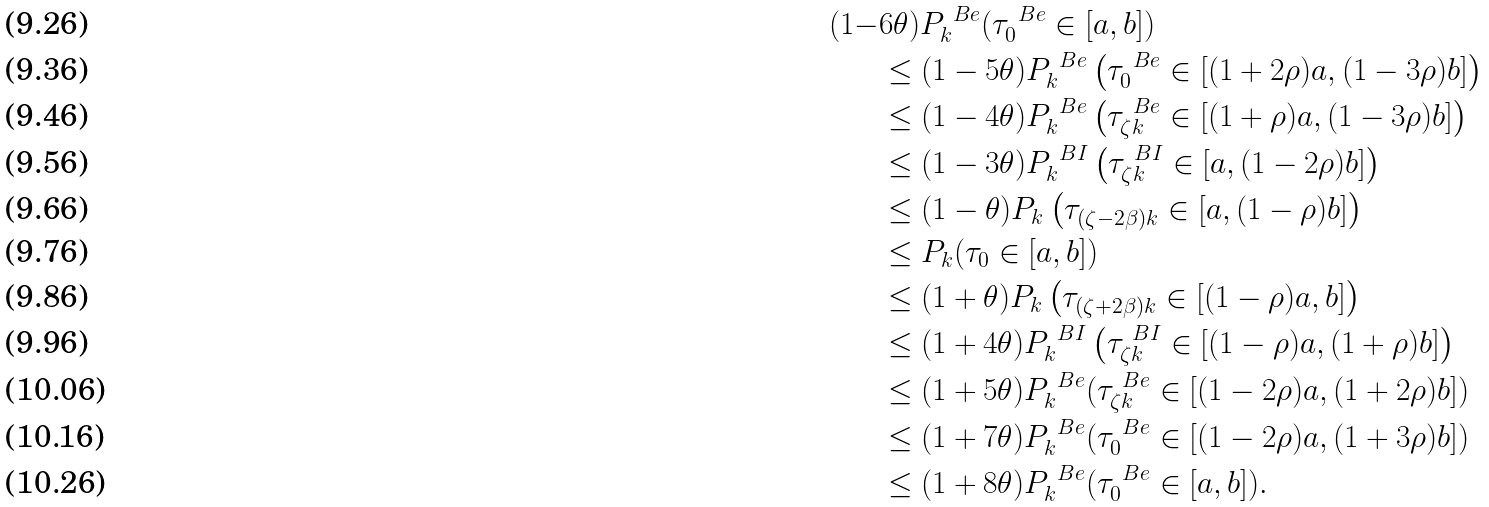Convert formula to latex. <formula><loc_0><loc_0><loc_500><loc_500>( 1 - & 6 \theta ) P _ { k } ^ { \ B e } ( \tau _ { 0 } ^ { \ B e } \in [ a , b ] ) \\ & \leq ( 1 - 5 \theta ) P _ { k } ^ { \ B e } \left ( \tau _ { 0 } ^ { \ B e } \in [ ( 1 + 2 \rho ) a , ( 1 - 3 \rho ) b ] \right ) \\ & \leq ( 1 - 4 \theta ) P _ { k } ^ { \ B e } \left ( \tau _ { \zeta k } ^ { \ B e } \in [ ( 1 + \rho ) a , ( 1 - 3 \rho ) b ] \right ) \\ & \leq ( 1 - 3 \theta ) P _ { k } ^ { \ B I } \left ( \tau _ { \zeta k } ^ { \ B I } \in [ a , ( 1 - 2 \rho ) b ] \right ) \\ & \leq ( 1 - \theta ) P _ { k } \left ( \tau _ { ( \zeta - 2 \beta ) k } \in [ a , ( 1 - \rho ) b ] \right ) \\ & \leq P _ { k } ( \tau _ { 0 } \in [ a , b ] ) \\ & \leq ( 1 + \theta ) P _ { k } \left ( \tau _ { ( \zeta + 2 \beta ) k } \in [ ( 1 - \rho ) a , b ] \right ) \\ & \leq ( 1 + 4 \theta ) P _ { k } ^ { \ B I } \left ( \tau _ { \zeta k } ^ { \ B I } \in [ ( 1 - \rho ) a , ( 1 + \rho ) b ] \right ) \\ & \leq ( 1 + 5 \theta ) P _ { k } ^ { \ B e } ( \tau _ { \zeta k } ^ { \ B e } \in [ ( 1 - 2 \rho ) a , ( 1 + 2 \rho ) b ] ) \\ & \leq ( 1 + 7 \theta ) P _ { k } ^ { \ B e } ( \tau _ { 0 } ^ { \ B e } \in [ ( 1 - 2 \rho ) a , ( 1 + 3 \rho ) b ] ) \\ & \leq ( 1 + 8 \theta ) P _ { k } ^ { \ B e } ( \tau _ { 0 } ^ { \ B e } \in [ a , b ] ) .</formula> 